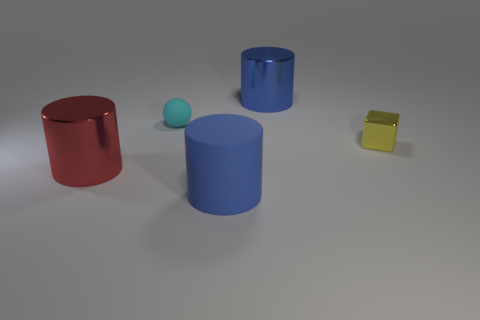If we think of these items as part of a modern art installation, what themes could they represent? Interpreting these objects as a modern art installation, we could say they explore themes like minimalism and the interplay between form, color, and space. The austerity of the shapes could represent the essence of the objects, stripped of complexity. The bright, primary colors placed against a muted background might suggest a commentary on the purity and simplicity of fundamental elements in both art and life, inviting viewers to contemplate the beauty in basic geometric forms. 